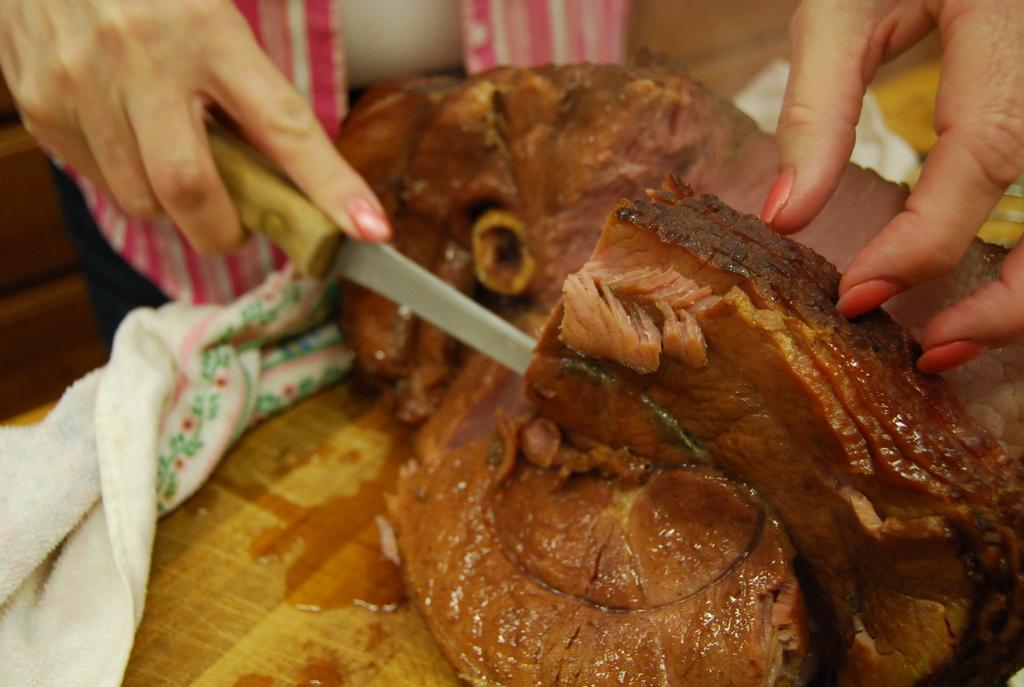Could you give a brief overview of what you see in this image? In the foreground of this image, on the table, there is meat and a persons holding a knife is cutting it and on the table, we can also see a white color cloth. 